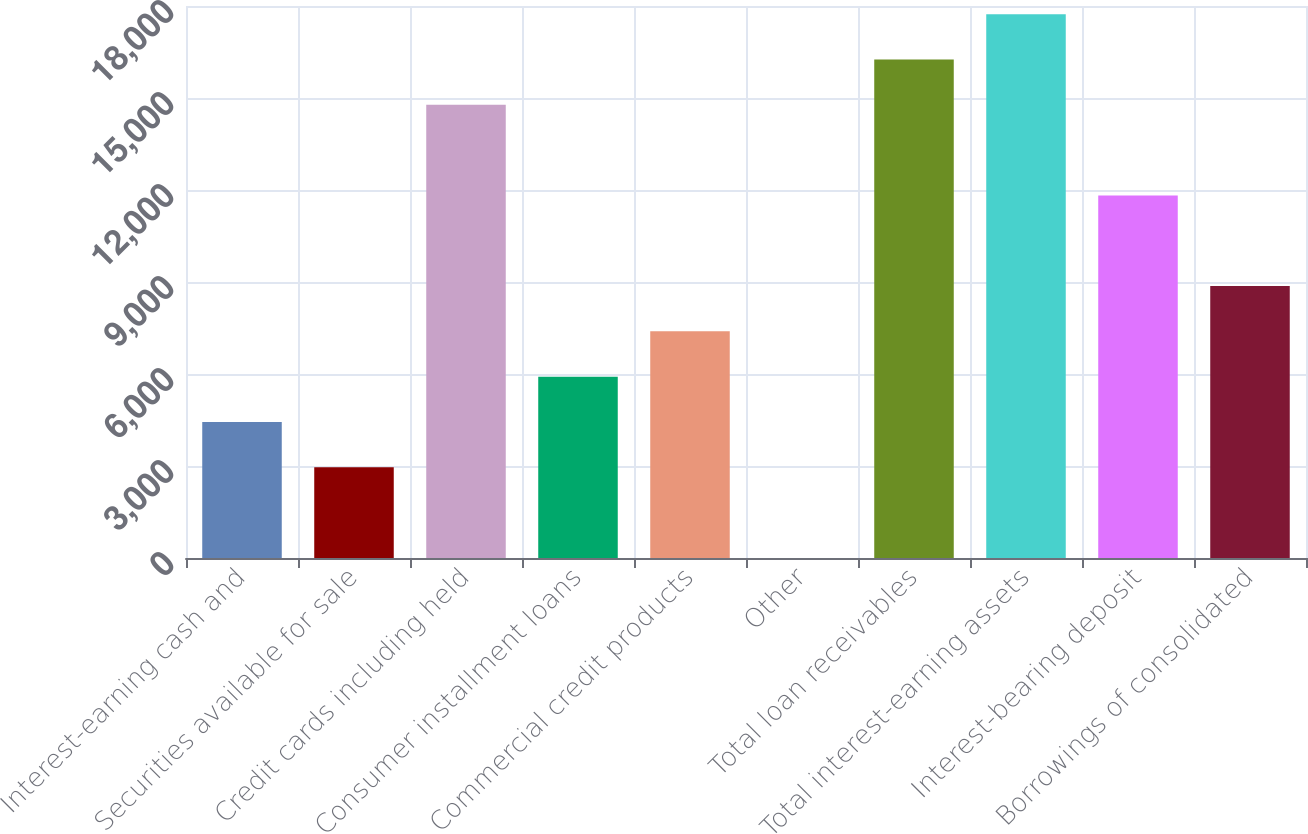<chart> <loc_0><loc_0><loc_500><loc_500><bar_chart><fcel>Interest-earning cash and<fcel>Securities available for sale<fcel>Credit cards including held<fcel>Consumer installment loans<fcel>Commercial credit products<fcel>Other<fcel>Total loan receivables<fcel>Total interest-earning assets<fcel>Interest-bearing deposit<fcel>Borrowings of consolidated<nl><fcel>4434.8<fcel>2957.2<fcel>14778<fcel>5912.4<fcel>7390<fcel>2<fcel>16255.6<fcel>17733.2<fcel>11822.8<fcel>8867.6<nl></chart> 